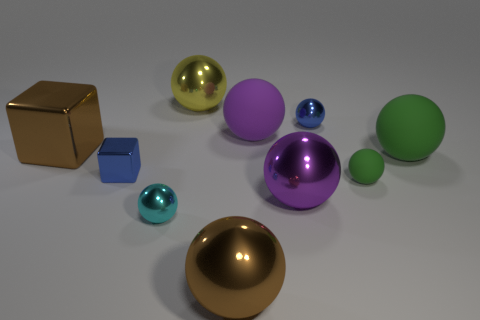How many large objects are cyan blocks or yellow shiny objects?
Provide a succinct answer. 1. Does the brown object in front of the purple metal thing have the same size as the blue metallic object in front of the large brown metal cube?
Offer a very short reply. No. What is the size of the brown metallic thing that is the same shape as the tiny cyan thing?
Your answer should be compact. Large. Is the number of yellow things on the left side of the big shiny cube greater than the number of tiny balls that are left of the tiny cube?
Offer a very short reply. No. What is the big sphere that is both behind the big green matte ball and in front of the yellow metal sphere made of?
Keep it short and to the point. Rubber. What is the color of the other big matte object that is the same shape as the large purple matte object?
Make the answer very short. Green. The blue metal cube is what size?
Your response must be concise. Small. There is a large sphere that is behind the large rubber object behind the large green rubber thing; what is its color?
Your answer should be very brief. Yellow. What number of big things are both in front of the tiny green sphere and behind the cyan ball?
Keep it short and to the point. 1. Is the number of shiny objects greater than the number of blue spheres?
Your answer should be compact. Yes. 